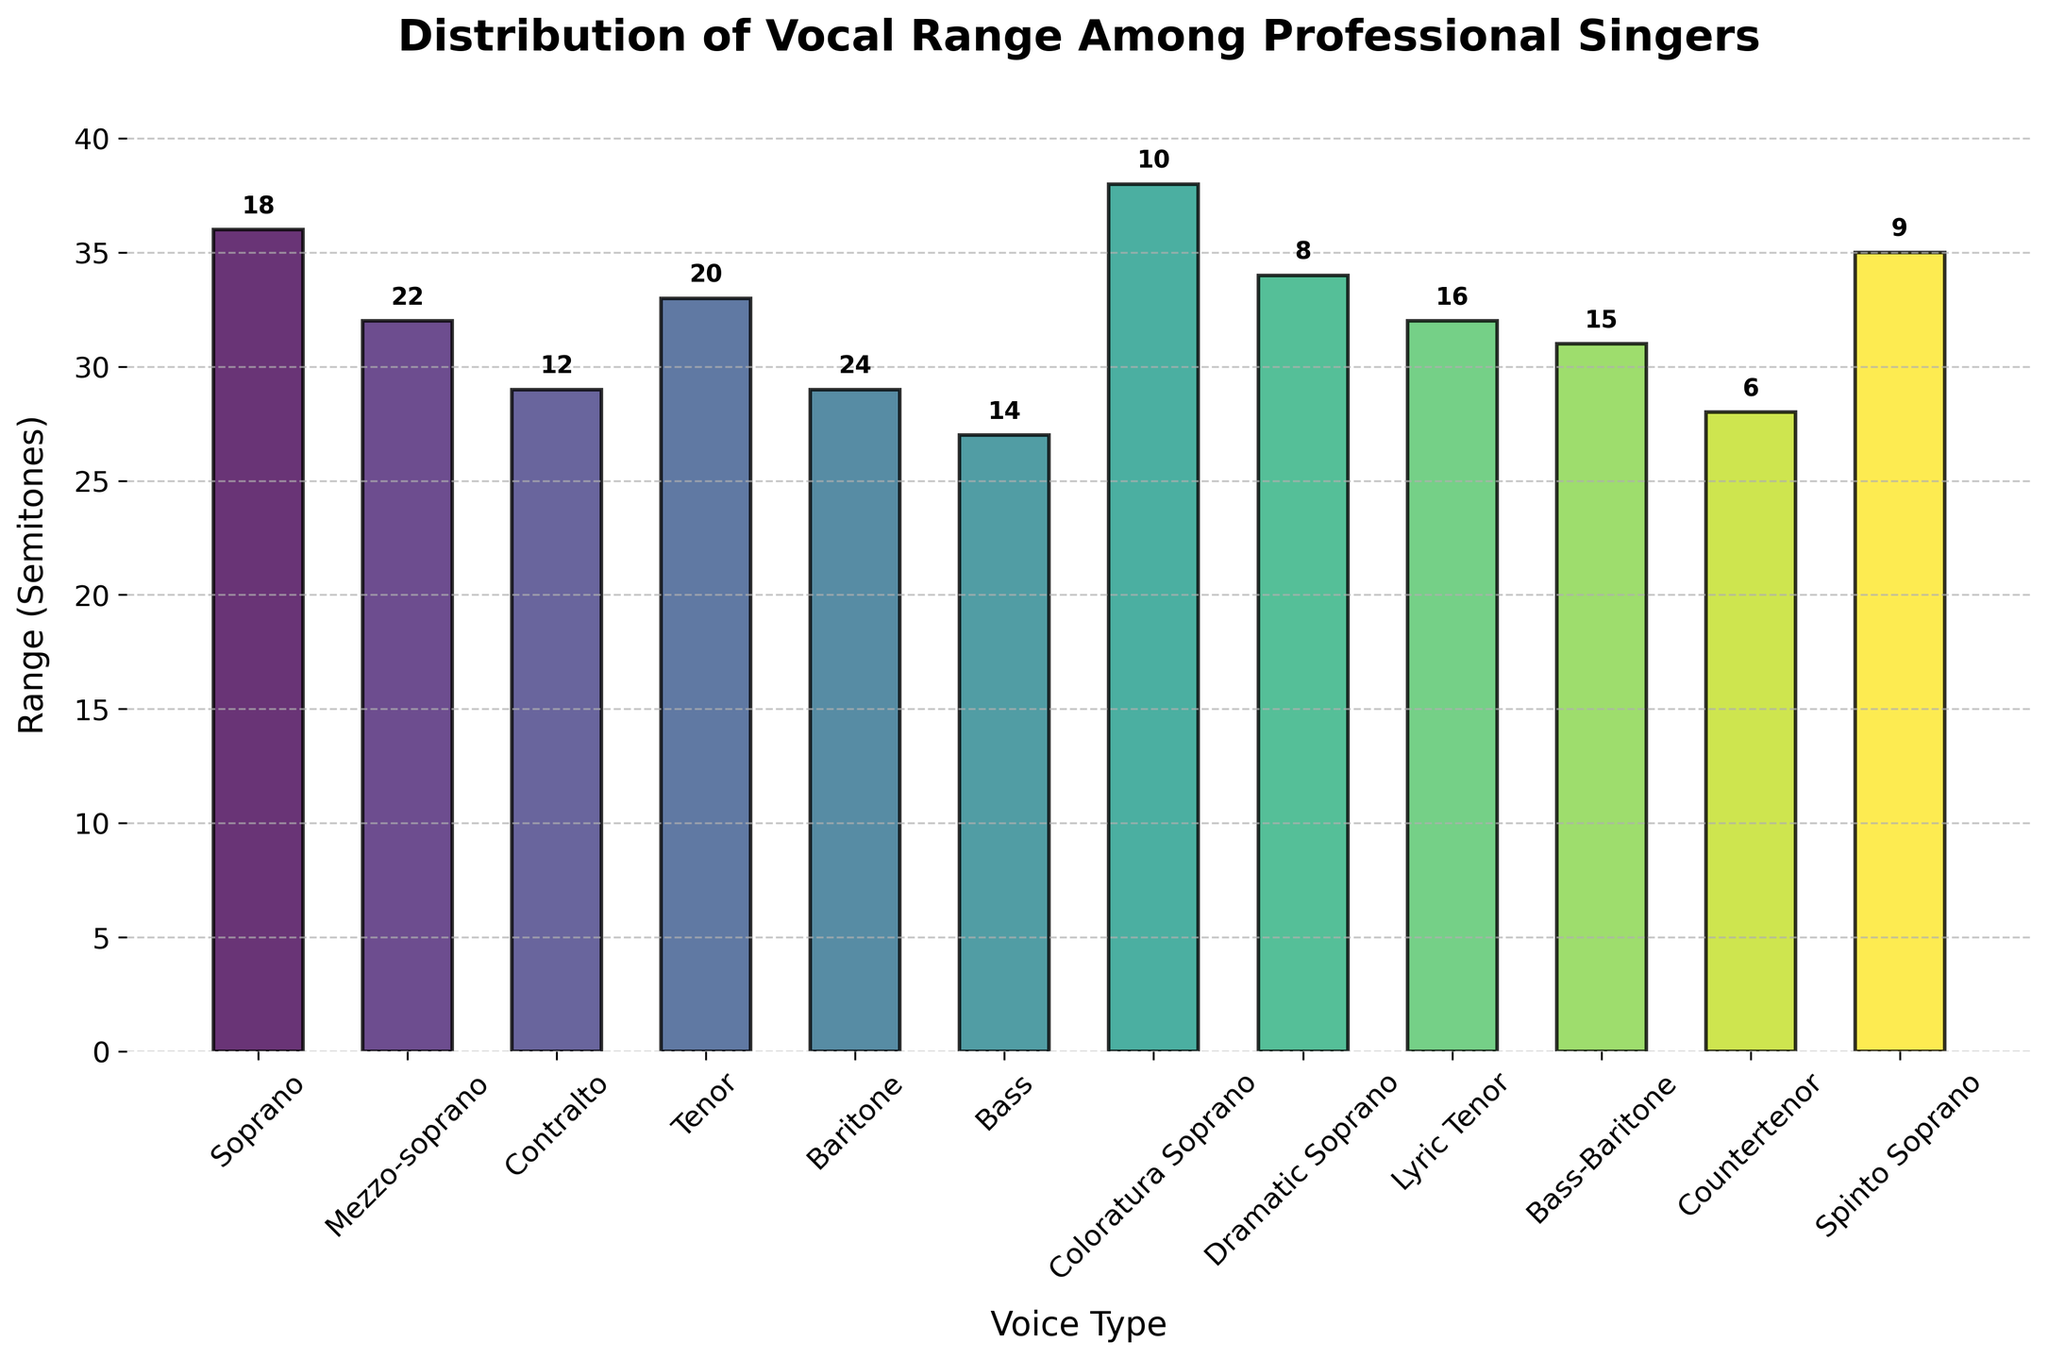What's the title of the plot? The title of the plot is shown at the top of the figure in a bold, large font.
Answer: Distribution of Vocal Range Among Professional Singers What is the range (in semitones) of a Baritone voice type? Look at the bar labeled "Baritone" and read the height on the y-axis.
Answer: 29 Which voice type has the highest vocal range? Compare the heights of all the bars and find the tallest one.
Answer: Coloratura Soprano What is the frequency of the Lyric Tenor voice type? Next to the bar labeled "Lyric Tenor," there's a number indicating its frequency.
Answer: 16 What is the total number of voice types represented in the histogram? Count the number of distinct bars corresponding to different voice types.
Answer: 12 How many voice types have a range greater than 30 semitones? Review each bar and count the number that exceeds 30 semitones.
Answer: 7 